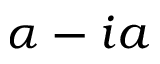<formula> <loc_0><loc_0><loc_500><loc_500>\alpha - i a</formula> 